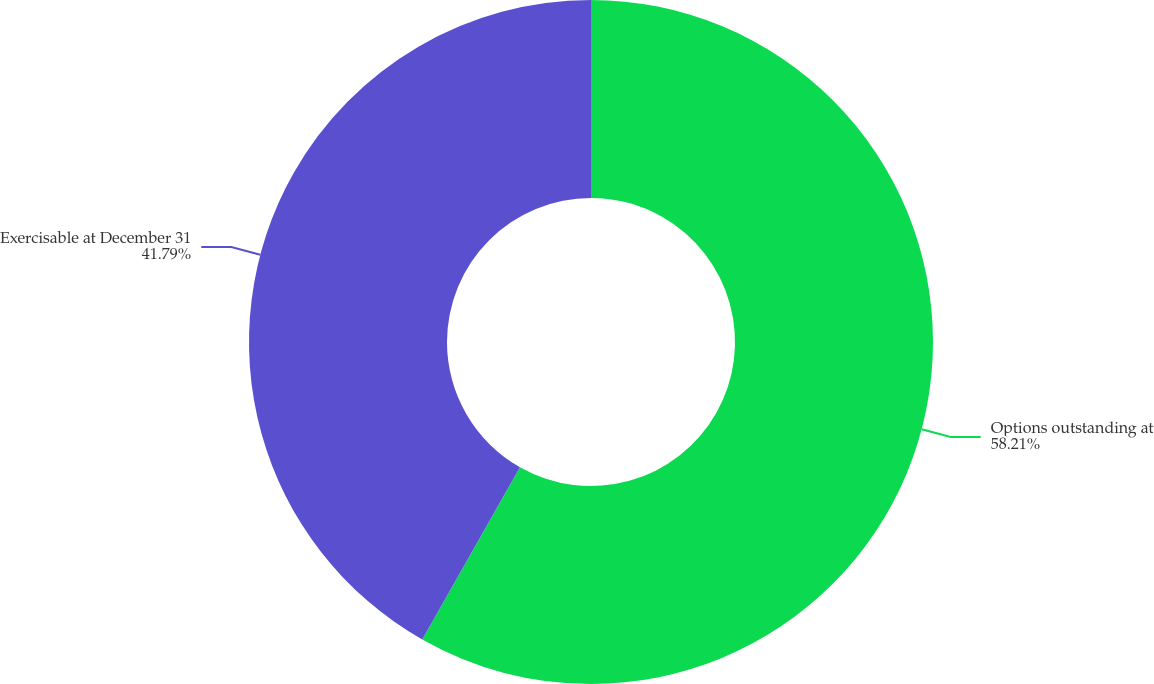Convert chart. <chart><loc_0><loc_0><loc_500><loc_500><pie_chart><fcel>Options outstanding at<fcel>Exercisable at December 31<nl><fcel>58.21%<fcel>41.79%<nl></chart> 